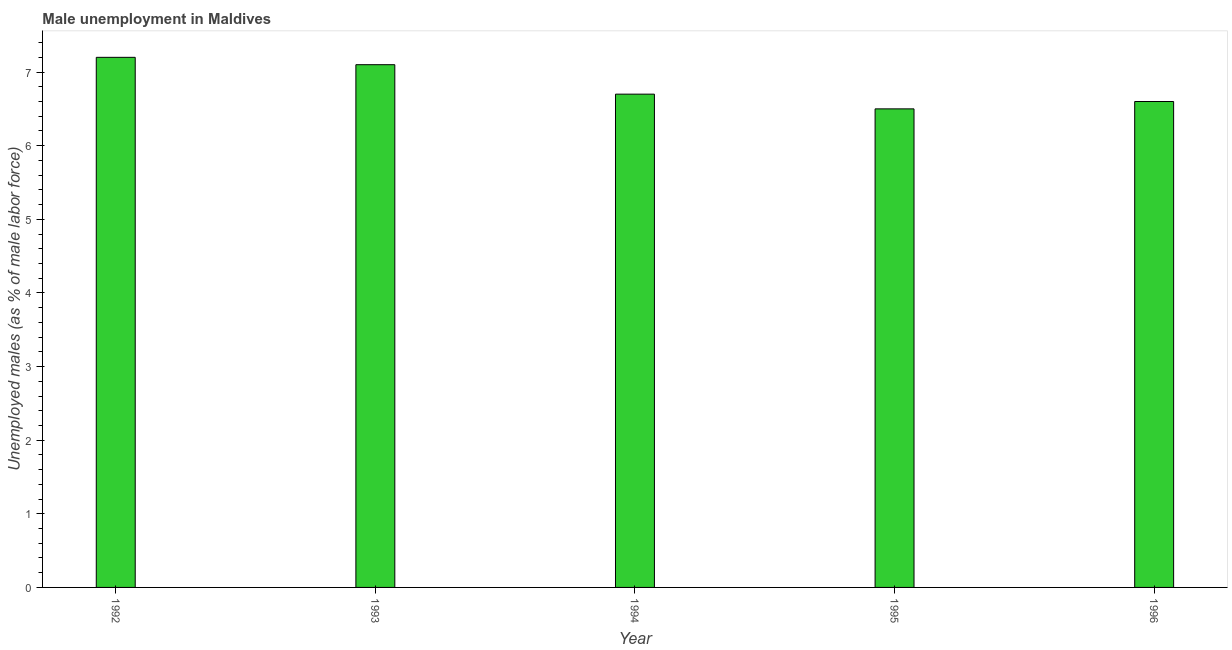Does the graph contain any zero values?
Your response must be concise. No. Does the graph contain grids?
Provide a succinct answer. No. What is the title of the graph?
Ensure brevity in your answer.  Male unemployment in Maldives. What is the label or title of the Y-axis?
Your answer should be very brief. Unemployed males (as % of male labor force). What is the unemployed males population in 1996?
Offer a very short reply. 6.6. Across all years, what is the maximum unemployed males population?
Offer a terse response. 7.2. Across all years, what is the minimum unemployed males population?
Offer a terse response. 6.5. What is the sum of the unemployed males population?
Offer a terse response. 34.1. What is the average unemployed males population per year?
Keep it short and to the point. 6.82. What is the median unemployed males population?
Give a very brief answer. 6.7. Do a majority of the years between 1993 and 1994 (inclusive) have unemployed males population greater than 6.6 %?
Provide a short and direct response. Yes. Is the difference between the unemployed males population in 1993 and 1996 greater than the difference between any two years?
Your answer should be very brief. No. What is the difference between the highest and the second highest unemployed males population?
Ensure brevity in your answer.  0.1. Is the sum of the unemployed males population in 1992 and 1996 greater than the maximum unemployed males population across all years?
Provide a short and direct response. Yes. What is the difference between the highest and the lowest unemployed males population?
Your response must be concise. 0.7. In how many years, is the unemployed males population greater than the average unemployed males population taken over all years?
Offer a terse response. 2. How many bars are there?
Provide a short and direct response. 5. How many years are there in the graph?
Your answer should be compact. 5. What is the difference between two consecutive major ticks on the Y-axis?
Offer a terse response. 1. What is the Unemployed males (as % of male labor force) in 1992?
Keep it short and to the point. 7.2. What is the Unemployed males (as % of male labor force) in 1993?
Give a very brief answer. 7.1. What is the Unemployed males (as % of male labor force) in 1994?
Provide a short and direct response. 6.7. What is the Unemployed males (as % of male labor force) in 1995?
Offer a very short reply. 6.5. What is the Unemployed males (as % of male labor force) of 1996?
Give a very brief answer. 6.6. What is the difference between the Unemployed males (as % of male labor force) in 1992 and 1993?
Ensure brevity in your answer.  0.1. What is the difference between the Unemployed males (as % of male labor force) in 1992 and 1994?
Provide a short and direct response. 0.5. What is the difference between the Unemployed males (as % of male labor force) in 1993 and 1994?
Provide a short and direct response. 0.4. What is the difference between the Unemployed males (as % of male labor force) in 1993 and 1995?
Offer a very short reply. 0.6. What is the difference between the Unemployed males (as % of male labor force) in 1993 and 1996?
Your response must be concise. 0.5. What is the difference between the Unemployed males (as % of male labor force) in 1994 and 1996?
Make the answer very short. 0.1. What is the ratio of the Unemployed males (as % of male labor force) in 1992 to that in 1994?
Your answer should be compact. 1.07. What is the ratio of the Unemployed males (as % of male labor force) in 1992 to that in 1995?
Make the answer very short. 1.11. What is the ratio of the Unemployed males (as % of male labor force) in 1992 to that in 1996?
Provide a short and direct response. 1.09. What is the ratio of the Unemployed males (as % of male labor force) in 1993 to that in 1994?
Make the answer very short. 1.06. What is the ratio of the Unemployed males (as % of male labor force) in 1993 to that in 1995?
Offer a very short reply. 1.09. What is the ratio of the Unemployed males (as % of male labor force) in 1993 to that in 1996?
Provide a short and direct response. 1.08. What is the ratio of the Unemployed males (as % of male labor force) in 1994 to that in 1995?
Provide a short and direct response. 1.03. 